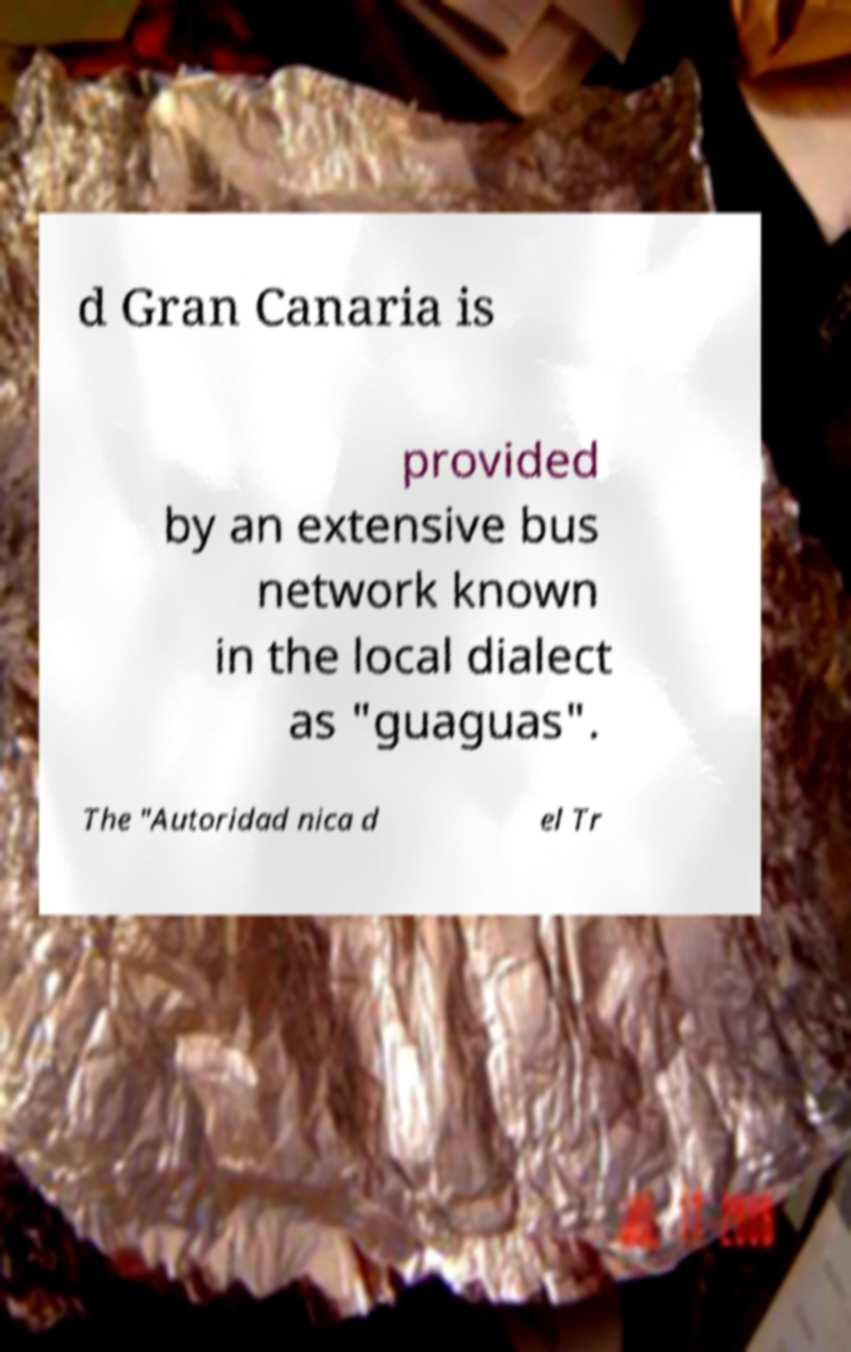For documentation purposes, I need the text within this image transcribed. Could you provide that? d Gran Canaria is provided by an extensive bus network known in the local dialect as "guaguas". The "Autoridad nica d el Tr 